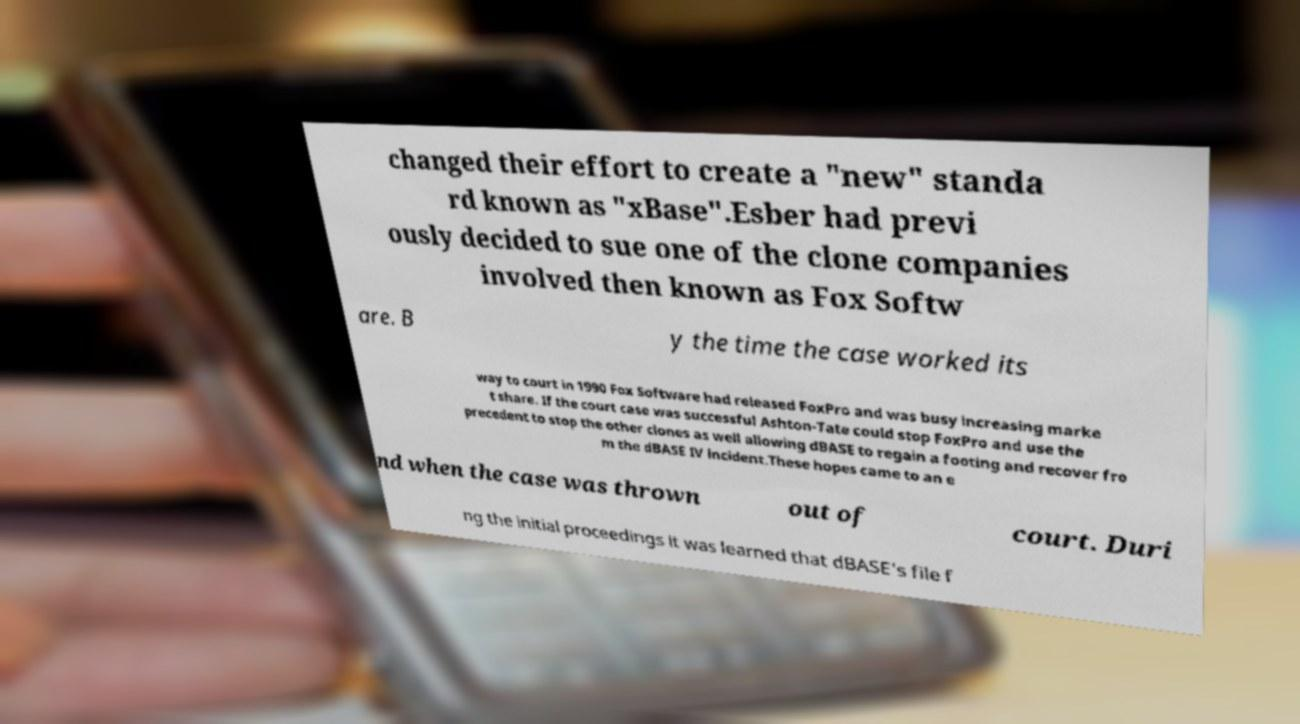Please read and relay the text visible in this image. What does it say? changed their effort to create a "new" standa rd known as "xBase".Esber had previ ously decided to sue one of the clone companies involved then known as Fox Softw are. B y the time the case worked its way to court in 1990 Fox Software had released FoxPro and was busy increasing marke t share. If the court case was successful Ashton-Tate could stop FoxPro and use the precedent to stop the other clones as well allowing dBASE to regain a footing and recover fro m the dBASE IV incident.These hopes came to an e nd when the case was thrown out of court. Duri ng the initial proceedings it was learned that dBASE's file f 